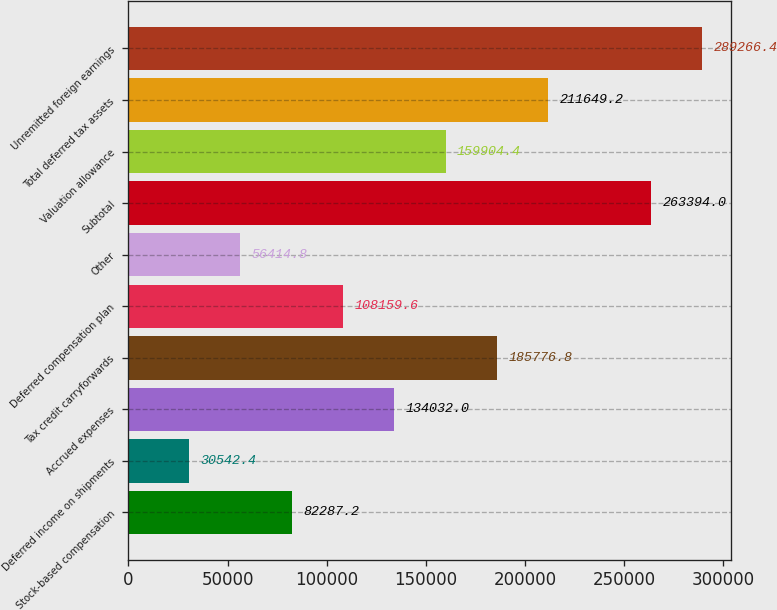<chart> <loc_0><loc_0><loc_500><loc_500><bar_chart><fcel>Stock-based compensation<fcel>Deferred income on shipments<fcel>Accrued expenses<fcel>Tax credit carryforwards<fcel>Deferred compensation plan<fcel>Other<fcel>Subtotal<fcel>Valuation allowance<fcel>Total deferred tax assets<fcel>Unremitted foreign earnings<nl><fcel>82287.2<fcel>30542.4<fcel>134032<fcel>185777<fcel>108160<fcel>56414.8<fcel>263394<fcel>159904<fcel>211649<fcel>289266<nl></chart> 